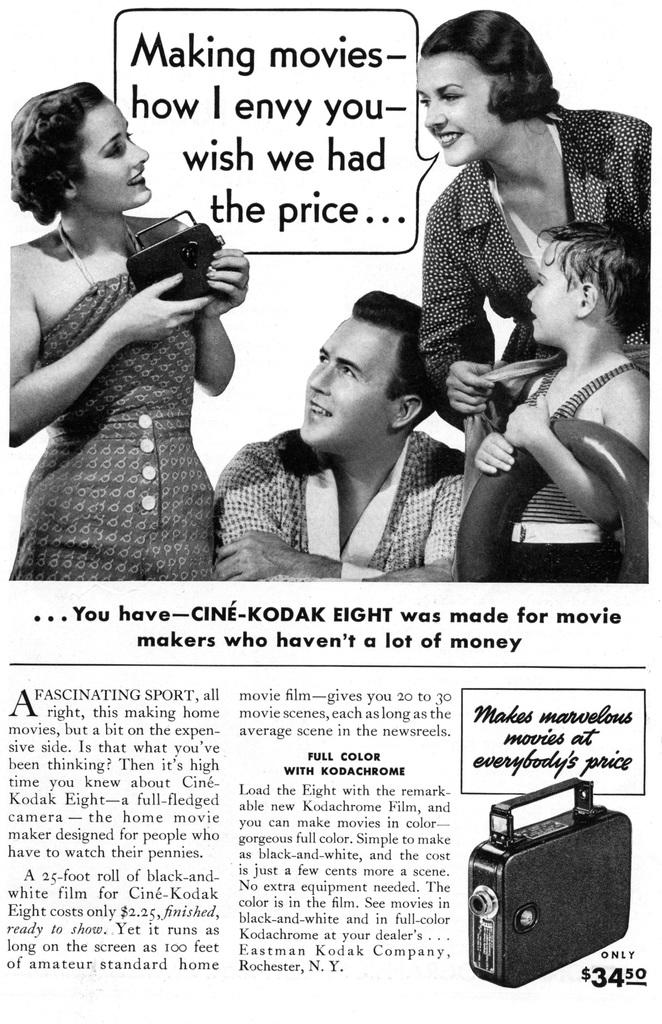What is the main subject of the newspaper article in the image? The main subject of the newspaper article in the image is about people. Can you describe the content of the newspaper article? The newspaper article mentions people, but the specific details cannot be determined from the image alone. What shape is the degree mentioned in the newspaper article? There is no mention of a degree in the newspaper article, and therefore no shape can be associated with it. 